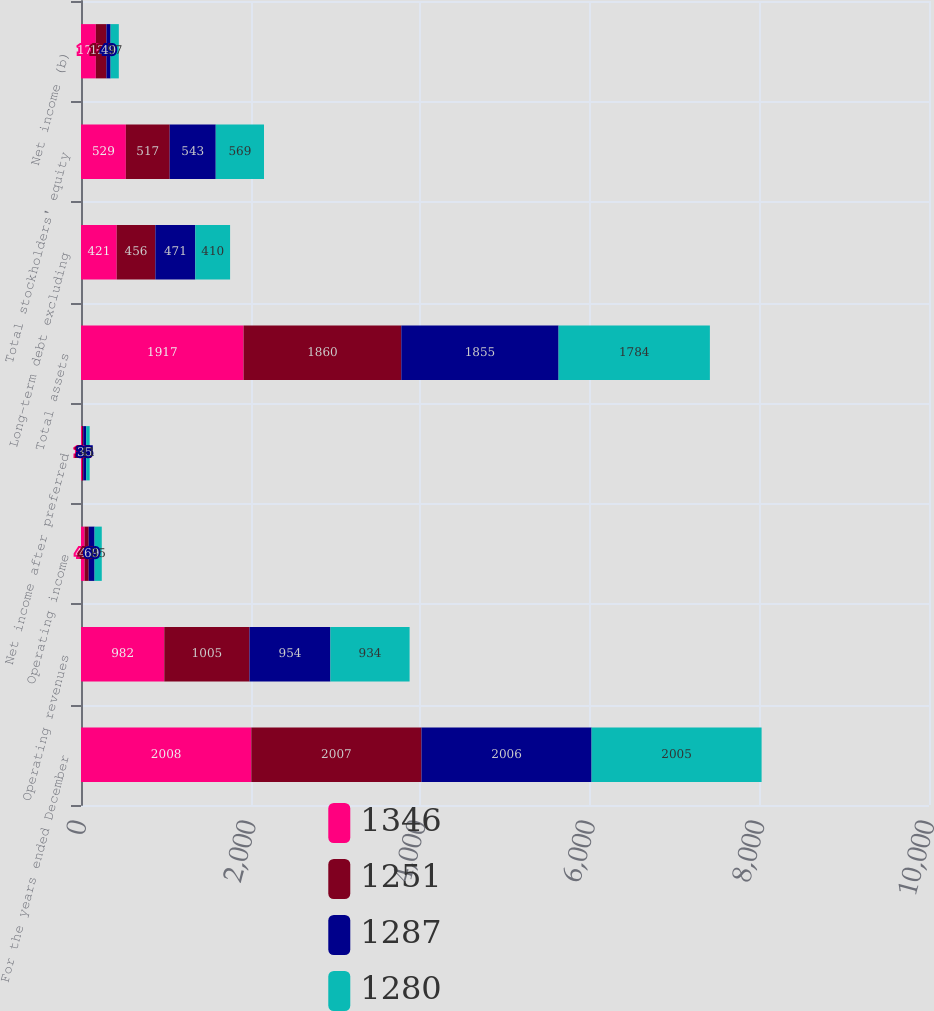<chart> <loc_0><loc_0><loc_500><loc_500><stacked_bar_chart><ecel><fcel>For the years ended December<fcel>Operating revenues<fcel>Operating income<fcel>Net income after preferred<fcel>Total assets<fcel>Long-term debt excluding<fcel>Total stockholders' equity<fcel>Net income (b)<nl><fcel>1346<fcel>2008<fcel>982<fcel>42<fcel>12<fcel>1917<fcel>421<fcel>529<fcel>175<nl><fcel>1251<fcel>2007<fcel>1005<fcel>49<fcel>14<fcel>1860<fcel>456<fcel>517<fcel>125<nl><fcel>1287<fcel>2006<fcel>954<fcel>69<fcel>35<fcel>1855<fcel>471<fcel>543<fcel>49<nl><fcel>1280<fcel>2005<fcel>934<fcel>85<fcel>41<fcel>1784<fcel>410<fcel>569<fcel>97<nl></chart> 